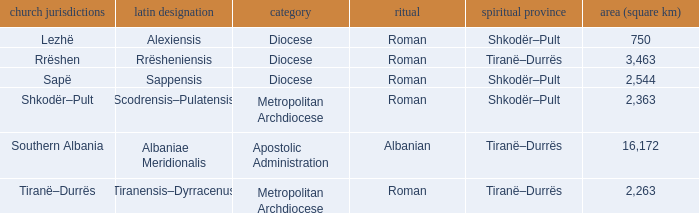Could you parse the entire table? {'header': ['church jurisdictions', 'latin designation', 'category', 'ritual', 'spiritual province', 'area (square km)'], 'rows': [['Lezhë', 'Alexiensis', 'Diocese', 'Roman', 'Shkodër–Pult', '750'], ['Rrëshen', 'Rrësheniensis', 'Diocese', 'Roman', 'Tiranë–Durrës', '3,463'], ['Sapë', 'Sappensis', 'Diocese', 'Roman', 'Shkodër–Pult', '2,544'], ['Shkodër–Pult', 'Scodrensis–Pulatensis', 'Metropolitan Archdiocese', 'Roman', 'Shkodër–Pult', '2,363'], ['Southern Albania', 'Albaniae Meridionalis', 'Apostolic Administration', 'Albanian', 'Tiranë–Durrës', '16,172'], ['Tiranë–Durrës', 'Tiranensis–Dyrracenus', 'Metropolitan Archdiocese', 'Roman', 'Tiranë–Durrës', '2,263']]} What is Type for Rite Albanian? Apostolic Administration. 